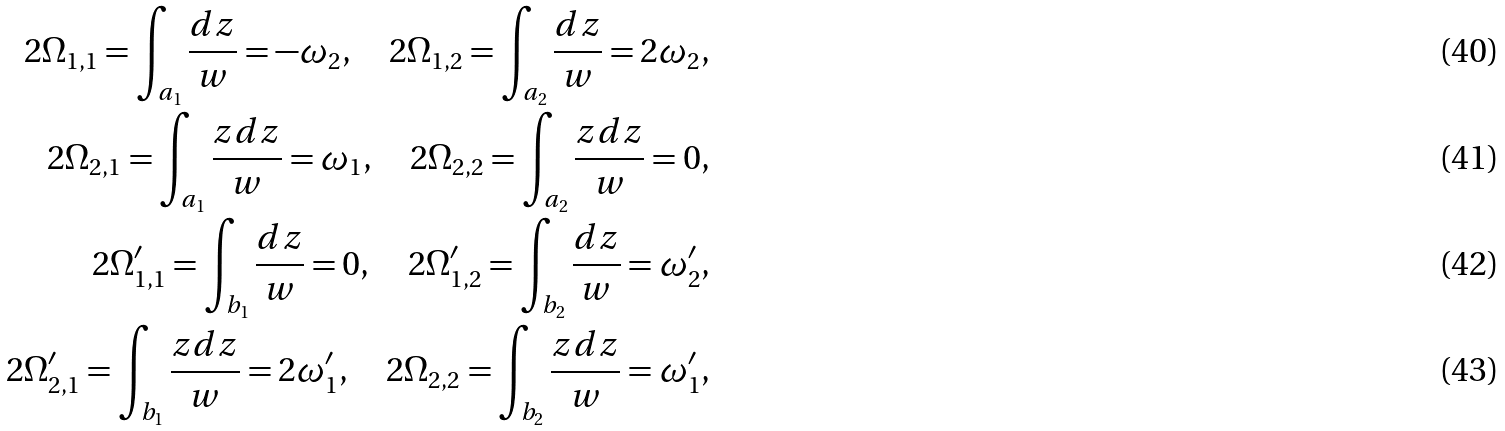Convert formula to latex. <formula><loc_0><loc_0><loc_500><loc_500>2 \Omega _ { 1 , 1 } = \int _ { a _ { 1 } } \frac { d z } { w } = - \omega _ { 2 } , \quad 2 \Omega _ { 1 , 2 } = \int _ { a _ { 2 } } \frac { d z } { w } = 2 \omega _ { 2 } , \\ 2 \Omega _ { 2 , 1 } = \int _ { a _ { 1 } } \frac { z d z } { w } = \omega _ { 1 } , \quad 2 \Omega _ { 2 , 2 } = \int _ { a _ { 2 } } \frac { z d z } { w } = 0 , \\ 2 \Omega _ { 1 , 1 } ^ { \prime } = \int _ { b _ { 1 } } \frac { d z } { w } = 0 , \quad 2 \Omega _ { 1 , 2 } ^ { \prime } = \int _ { b _ { 2 } } \frac { d z } { w } = \omega _ { 2 } ^ { \prime } , \\ 2 \Omega _ { 2 , 1 } ^ { \prime } = \int _ { b _ { 1 } } \frac { z d z } { w } = 2 \omega _ { 1 } ^ { \prime } , \quad 2 \Omega _ { 2 , 2 } = \int _ { b _ { 2 } } \frac { z d z } { w } = \omega _ { 1 } ^ { \prime } ,</formula> 